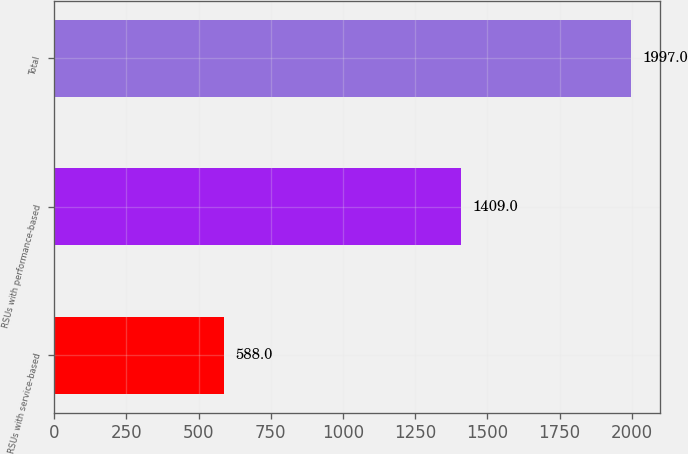Convert chart. <chart><loc_0><loc_0><loc_500><loc_500><bar_chart><fcel>RSUs with service-based<fcel>RSUs with performance-based<fcel>Total<nl><fcel>588<fcel>1409<fcel>1997<nl></chart> 